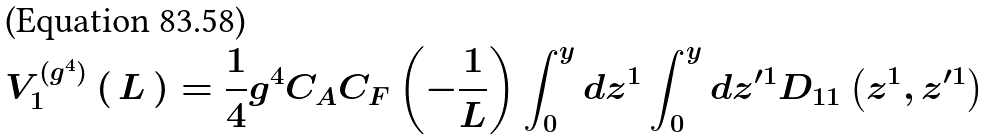Convert formula to latex. <formula><loc_0><loc_0><loc_500><loc_500>V _ { 1 } ^ { ( g ^ { 4 } ) } \left ( \, L \, \right ) = \frac { 1 } { 4 } g ^ { 4 } C _ { A } C _ { F } \left ( { - \frac { 1 } { L } } \right ) \int _ { 0 } ^ { y } { d z ^ { 1 } } \int _ { 0 } ^ { y } { d z ^ { \prime 1 } } D _ { 1 1 } \left ( { z ^ { 1 } , z ^ { \prime 1 } } \right )</formula> 